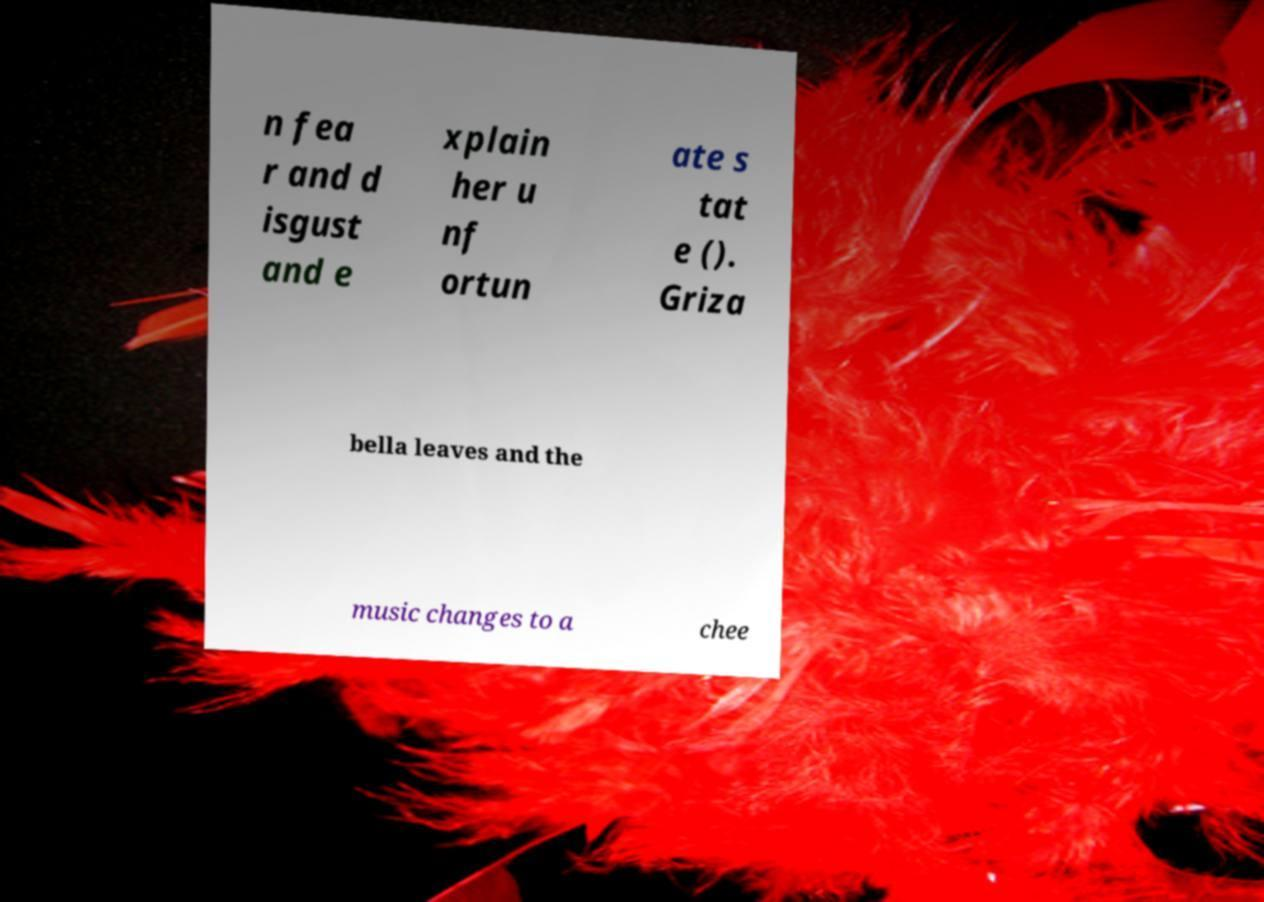Please identify and transcribe the text found in this image. n fea r and d isgust and e xplain her u nf ortun ate s tat e (). Griza bella leaves and the music changes to a chee 